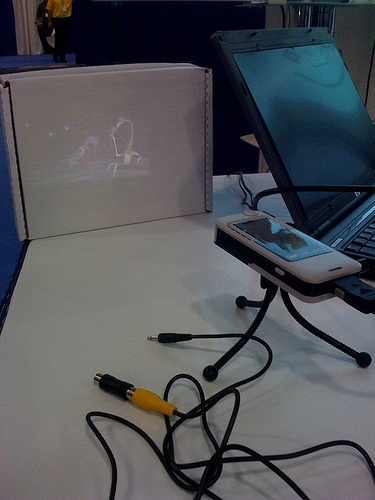Describe the objects in this image and their specific colors. I can see laptop in black, blue, darkblue, and teal tones, cell phone in black, gray, and blue tones, and people in black, maroon, and gray tones in this image. 